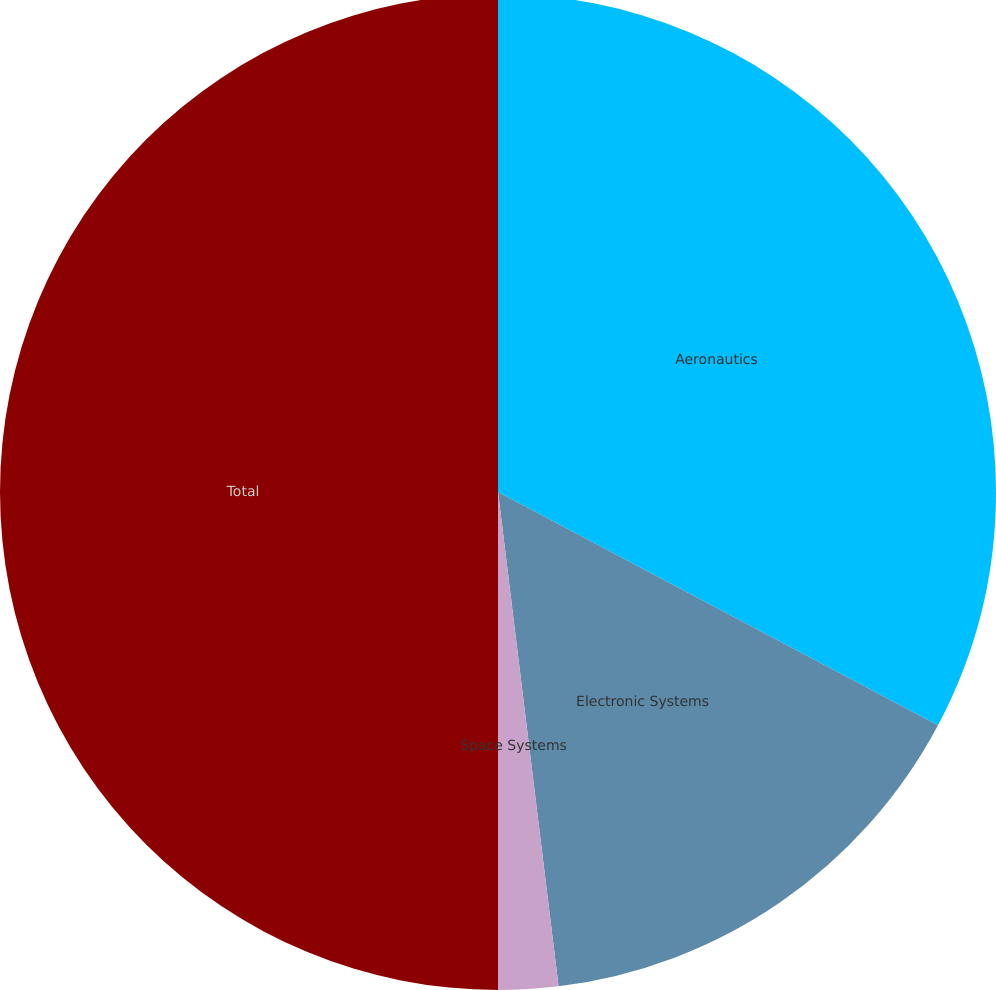Convert chart to OTSL. <chart><loc_0><loc_0><loc_500><loc_500><pie_chart><fcel>Aeronautics<fcel>Electronic Systems<fcel>Space Systems<fcel>Total<nl><fcel>32.76%<fcel>15.3%<fcel>1.94%<fcel>50.0%<nl></chart> 